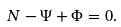Convert formula to latex. <formula><loc_0><loc_0><loc_500><loc_500>N - \Psi + \Phi = 0 .</formula> 